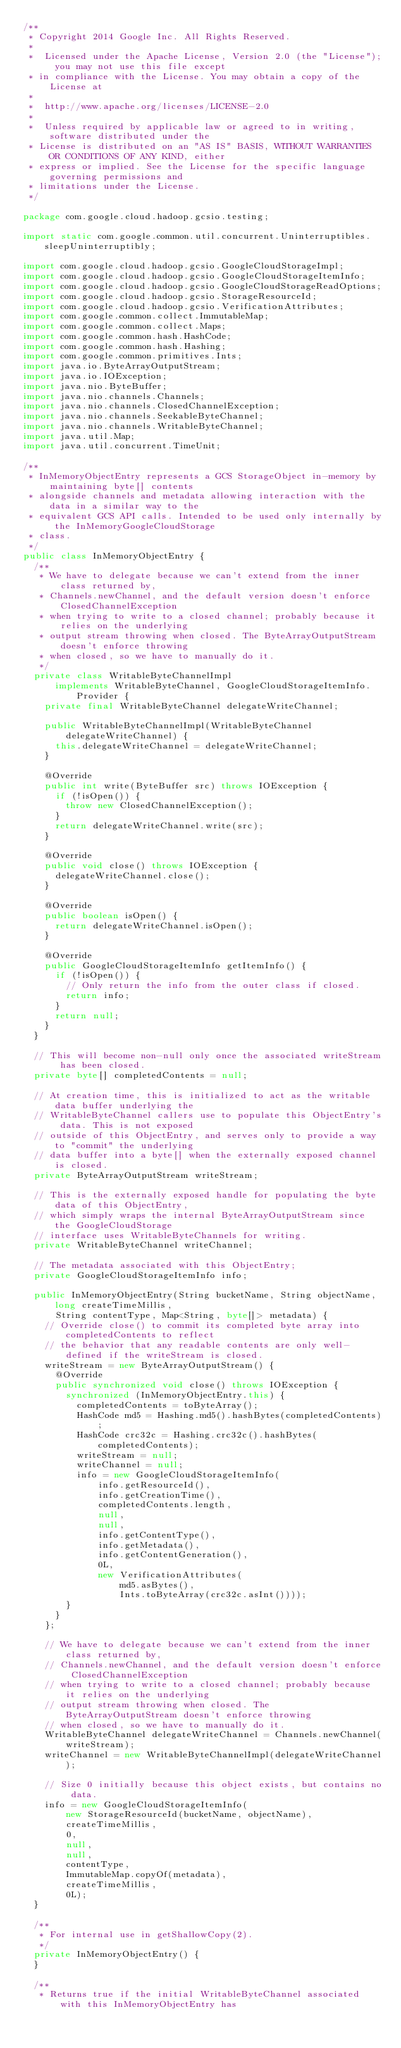Convert code to text. <code><loc_0><loc_0><loc_500><loc_500><_Java_>/**
 * Copyright 2014 Google Inc. All Rights Reserved.
 *
 *  Licensed under the Apache License, Version 2.0 (the "License"); you may not use this file except
 * in compliance with the License. You may obtain a copy of the License at
 *
 *  http://www.apache.org/licenses/LICENSE-2.0
 *
 *  Unless required by applicable law or agreed to in writing, software distributed under the
 * License is distributed on an "AS IS" BASIS, WITHOUT WARRANTIES OR CONDITIONS OF ANY KIND, either
 * express or implied. See the License for the specific language governing permissions and
 * limitations under the License.
 */

package com.google.cloud.hadoop.gcsio.testing;

import static com.google.common.util.concurrent.Uninterruptibles.sleepUninterruptibly;

import com.google.cloud.hadoop.gcsio.GoogleCloudStorageImpl;
import com.google.cloud.hadoop.gcsio.GoogleCloudStorageItemInfo;
import com.google.cloud.hadoop.gcsio.GoogleCloudStorageReadOptions;
import com.google.cloud.hadoop.gcsio.StorageResourceId;
import com.google.cloud.hadoop.gcsio.VerificationAttributes;
import com.google.common.collect.ImmutableMap;
import com.google.common.collect.Maps;
import com.google.common.hash.HashCode;
import com.google.common.hash.Hashing;
import com.google.common.primitives.Ints;
import java.io.ByteArrayOutputStream;
import java.io.IOException;
import java.nio.ByteBuffer;
import java.nio.channels.Channels;
import java.nio.channels.ClosedChannelException;
import java.nio.channels.SeekableByteChannel;
import java.nio.channels.WritableByteChannel;
import java.util.Map;
import java.util.concurrent.TimeUnit;

/**
 * InMemoryObjectEntry represents a GCS StorageObject in-memory by maintaining byte[] contents
 * alongside channels and metadata allowing interaction with the data in a similar way to the
 * equivalent GCS API calls. Intended to be used only internally by the InMemoryGoogleCloudStorage
 * class.
 */
public class InMemoryObjectEntry {
  /**
   * We have to delegate because we can't extend from the inner class returned by,
   * Channels.newChannel, and the default version doesn't enforce ClosedChannelException
   * when trying to write to a closed channel; probably because it relies on the underlying
   * output stream throwing when closed. The ByteArrayOutputStream doesn't enforce throwing
   * when closed, so we have to manually do it.
   */
  private class WritableByteChannelImpl
      implements WritableByteChannel, GoogleCloudStorageItemInfo.Provider {
    private final WritableByteChannel delegateWriteChannel;

    public WritableByteChannelImpl(WritableByteChannel delegateWriteChannel) {
      this.delegateWriteChannel = delegateWriteChannel;
    }

    @Override
    public int write(ByteBuffer src) throws IOException {
      if (!isOpen()) {
        throw new ClosedChannelException();
      }
      return delegateWriteChannel.write(src);
    }

    @Override
    public void close() throws IOException {
      delegateWriteChannel.close();
    }

    @Override
    public boolean isOpen() {
      return delegateWriteChannel.isOpen();
    }

    @Override
    public GoogleCloudStorageItemInfo getItemInfo() {
      if (!isOpen()) {
        // Only return the info from the outer class if closed.
        return info;
      }
      return null;
    }
  }

  // This will become non-null only once the associated writeStream has been closed.
  private byte[] completedContents = null;

  // At creation time, this is initialized to act as the writable data buffer underlying the
  // WritableByteChannel callers use to populate this ObjectEntry's data. This is not exposed
  // outside of this ObjectEntry, and serves only to provide a way to "commit" the underlying
  // data buffer into a byte[] when the externally exposed channel is closed.
  private ByteArrayOutputStream writeStream;

  // This is the externally exposed handle for populating the byte data of this ObjectEntry,
  // which simply wraps the internal ByteArrayOutputStream since the GoogleCloudStorage
  // interface uses WritableByteChannels for writing.
  private WritableByteChannel writeChannel;

  // The metadata associated with this ObjectEntry;
  private GoogleCloudStorageItemInfo info;

  public InMemoryObjectEntry(String bucketName, String objectName, long createTimeMillis,
      String contentType, Map<String, byte[]> metadata) {
    // Override close() to commit its completed byte array into completedContents to reflect
    // the behavior that any readable contents are only well-defined if the writeStream is closed.
    writeStream = new ByteArrayOutputStream() {
      @Override
      public synchronized void close() throws IOException {
        synchronized (InMemoryObjectEntry.this) {
          completedContents = toByteArray();
          HashCode md5 = Hashing.md5().hashBytes(completedContents);
          HashCode crc32c = Hashing.crc32c().hashBytes(completedContents);
          writeStream = null;
          writeChannel = null;
          info = new GoogleCloudStorageItemInfo(
              info.getResourceId(),
              info.getCreationTime(),
              completedContents.length,
              null,
              null,
              info.getContentType(),
              info.getMetadata(),
              info.getContentGeneration(),
              0L,
              new VerificationAttributes(
                  md5.asBytes(),
                  Ints.toByteArray(crc32c.asInt())));
        }
      }
    };

    // We have to delegate because we can't extend from the inner class returned by,
    // Channels.newChannel, and the default version doesn't enforce ClosedChannelException
    // when trying to write to a closed channel; probably because it relies on the underlying
    // output stream throwing when closed. The ByteArrayOutputStream doesn't enforce throwing
    // when closed, so we have to manually do it.
    WritableByteChannel delegateWriteChannel = Channels.newChannel(writeStream);
    writeChannel = new WritableByteChannelImpl(delegateWriteChannel);

    // Size 0 initially because this object exists, but contains no data.
    info = new GoogleCloudStorageItemInfo(
        new StorageResourceId(bucketName, objectName),
        createTimeMillis,
        0,
        null,
        null,
        contentType,
        ImmutableMap.copyOf(metadata),
        createTimeMillis,
        0L);
  }

  /**
   * For internal use in getShallowCopy(2).
   */
  private InMemoryObjectEntry() {
  }

  /**
   * Returns true if the initial WritableByteChannel associated with this InMemoryObjectEntry has</code> 